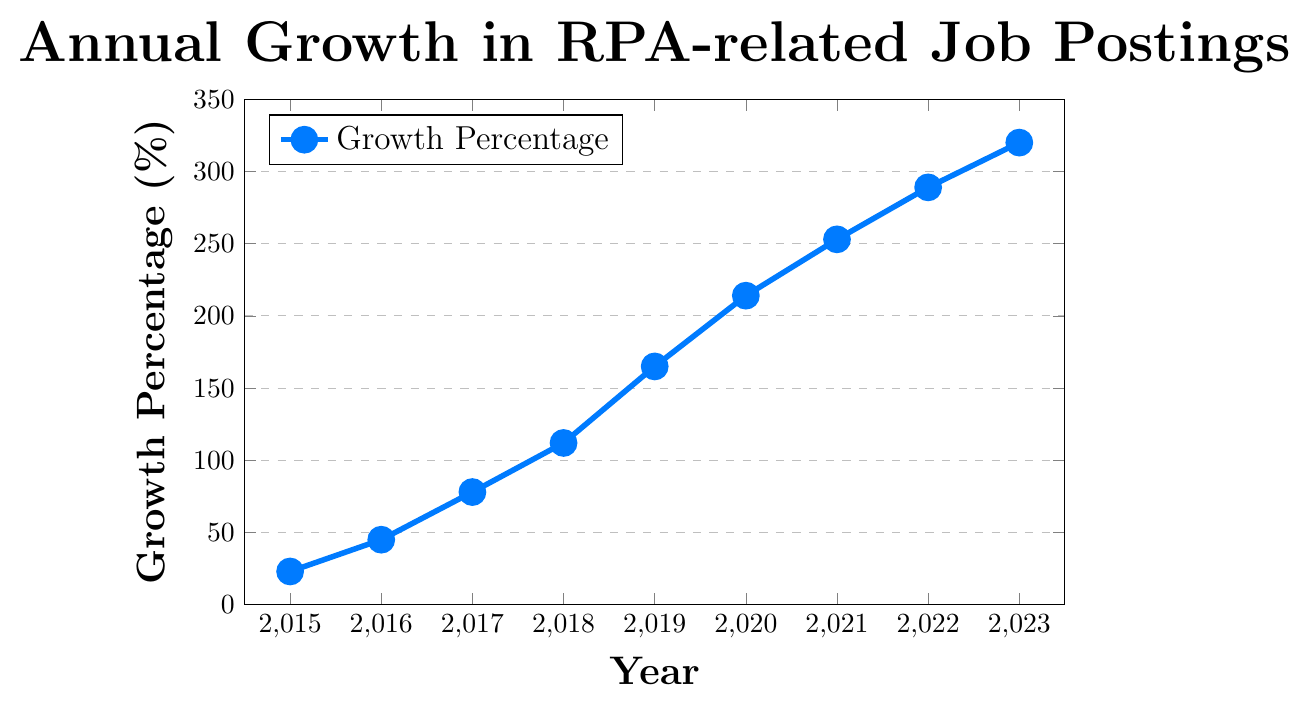What's the overall trend in RPA-related job postings from 2015 to 2023? To determine the overall trend, observe the data points from 2015 to 2023. The growth percentage consistently increases each year, indicating a rising trend.
Answer: Rising trend How much did the growth percentage increase between 2015 and 2023? Subtract the growth percentage of 2015 from that of 2023: 320 - 23. Calculate the difference to find the increase.
Answer: 297 Which year saw the highest growth percentage in RPA-related job postings? Examine the data points on the chart. The highest point on the y-axis corresponds to the year 2023, with a growth percentage of 320.
Answer: 2023 How does the growth in 2020 compare to that in 2019? Compare the data points for 2019 and 2020. The growth in 2020 (214) is higher than in 2019 (165).
Answer: Higher What is the average annual growth percentage from 2015 to 2023? Calculate the sum of growth percentages from 2015 to 2023 and divide by the number of years. (23+45+78+112+165+214+253+289+320) / 9. The total sum is 1499, and dividing by 9 gives the average.
Answer: 166.56 What is the difference in growth percentage between 2018 and 2016? Subtract the growth percentage in 2016 from that in 2018: 112 - 45. Calculate the difference.
Answer: 67 In what year did the growth percentage first exceed 100%? Look for the first data point where the growth percentage surpasses 100%. The year 2018 has a growth percentage of 112, which is the first instance above 100%.
Answer: 2018 What is the median growth percentage from 2015 to 2023? Arrange the growth percentages in ascending order and find the median (middle value). The sorted values are: 23, 45, 78, 112, 165, 214, 253, 289, 320. The median value, being the 5th value in the sorted list, is 165.
Answer: 165 How steep is the increase in growth percentage from 2019 to 2020 compared to 2016 to 2017? Calculate the difference for each interval: 2019-2020: 214 - 165 = 49; 2016-2017: 78 - 45 = 33. The increase from 2019 to 2020 is steeper than that from 2016 to 2017.
Answer: Steeper Describe the color used for the data points on the plot. The color used for the data points and the line in the plot is blue.
Answer: Blue 